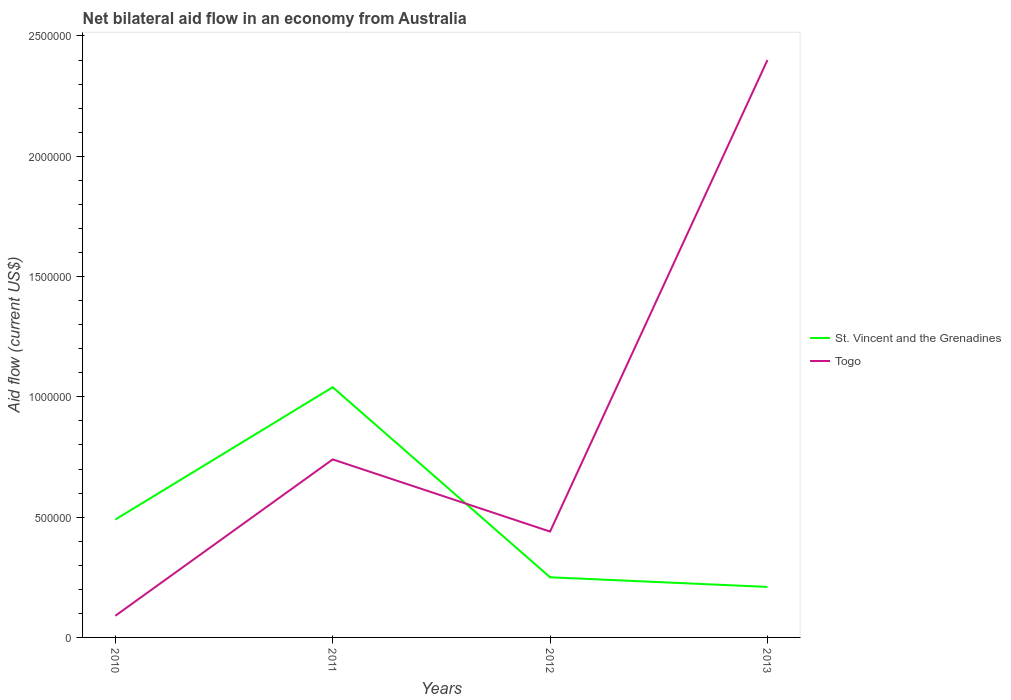Is the number of lines equal to the number of legend labels?
Provide a succinct answer. Yes. Across all years, what is the maximum net bilateral aid flow in Togo?
Give a very brief answer. 9.00e+04. In which year was the net bilateral aid flow in Togo maximum?
Offer a terse response. 2010. What is the total net bilateral aid flow in St. Vincent and the Grenadines in the graph?
Your answer should be very brief. 2.80e+05. What is the difference between the highest and the second highest net bilateral aid flow in St. Vincent and the Grenadines?
Provide a short and direct response. 8.30e+05. How many legend labels are there?
Give a very brief answer. 2. What is the title of the graph?
Your answer should be compact. Net bilateral aid flow in an economy from Australia. What is the label or title of the X-axis?
Your answer should be very brief. Years. What is the label or title of the Y-axis?
Ensure brevity in your answer.  Aid flow (current US$). What is the Aid flow (current US$) of St. Vincent and the Grenadines in 2010?
Your response must be concise. 4.90e+05. What is the Aid flow (current US$) of St. Vincent and the Grenadines in 2011?
Give a very brief answer. 1.04e+06. What is the Aid flow (current US$) in Togo in 2011?
Ensure brevity in your answer.  7.40e+05. What is the Aid flow (current US$) in St. Vincent and the Grenadines in 2012?
Provide a short and direct response. 2.50e+05. What is the Aid flow (current US$) in St. Vincent and the Grenadines in 2013?
Make the answer very short. 2.10e+05. What is the Aid flow (current US$) in Togo in 2013?
Keep it short and to the point. 2.40e+06. Across all years, what is the maximum Aid flow (current US$) in St. Vincent and the Grenadines?
Provide a succinct answer. 1.04e+06. Across all years, what is the maximum Aid flow (current US$) in Togo?
Your answer should be very brief. 2.40e+06. Across all years, what is the minimum Aid flow (current US$) of Togo?
Make the answer very short. 9.00e+04. What is the total Aid flow (current US$) of St. Vincent and the Grenadines in the graph?
Ensure brevity in your answer.  1.99e+06. What is the total Aid flow (current US$) of Togo in the graph?
Ensure brevity in your answer.  3.67e+06. What is the difference between the Aid flow (current US$) in St. Vincent and the Grenadines in 2010 and that in 2011?
Give a very brief answer. -5.50e+05. What is the difference between the Aid flow (current US$) of Togo in 2010 and that in 2011?
Offer a very short reply. -6.50e+05. What is the difference between the Aid flow (current US$) in Togo in 2010 and that in 2012?
Offer a terse response. -3.50e+05. What is the difference between the Aid flow (current US$) in St. Vincent and the Grenadines in 2010 and that in 2013?
Ensure brevity in your answer.  2.80e+05. What is the difference between the Aid flow (current US$) of Togo in 2010 and that in 2013?
Keep it short and to the point. -2.31e+06. What is the difference between the Aid flow (current US$) of St. Vincent and the Grenadines in 2011 and that in 2012?
Provide a succinct answer. 7.90e+05. What is the difference between the Aid flow (current US$) of St. Vincent and the Grenadines in 2011 and that in 2013?
Your answer should be compact. 8.30e+05. What is the difference between the Aid flow (current US$) in Togo in 2011 and that in 2013?
Your answer should be very brief. -1.66e+06. What is the difference between the Aid flow (current US$) in St. Vincent and the Grenadines in 2012 and that in 2013?
Provide a succinct answer. 4.00e+04. What is the difference between the Aid flow (current US$) in Togo in 2012 and that in 2013?
Keep it short and to the point. -1.96e+06. What is the difference between the Aid flow (current US$) of St. Vincent and the Grenadines in 2010 and the Aid flow (current US$) of Togo in 2011?
Make the answer very short. -2.50e+05. What is the difference between the Aid flow (current US$) of St. Vincent and the Grenadines in 2010 and the Aid flow (current US$) of Togo in 2013?
Offer a very short reply. -1.91e+06. What is the difference between the Aid flow (current US$) of St. Vincent and the Grenadines in 2011 and the Aid flow (current US$) of Togo in 2013?
Your answer should be compact. -1.36e+06. What is the difference between the Aid flow (current US$) in St. Vincent and the Grenadines in 2012 and the Aid flow (current US$) in Togo in 2013?
Make the answer very short. -2.15e+06. What is the average Aid flow (current US$) of St. Vincent and the Grenadines per year?
Provide a short and direct response. 4.98e+05. What is the average Aid flow (current US$) in Togo per year?
Your answer should be compact. 9.18e+05. In the year 2011, what is the difference between the Aid flow (current US$) in St. Vincent and the Grenadines and Aid flow (current US$) in Togo?
Keep it short and to the point. 3.00e+05. In the year 2013, what is the difference between the Aid flow (current US$) of St. Vincent and the Grenadines and Aid flow (current US$) of Togo?
Your answer should be compact. -2.19e+06. What is the ratio of the Aid flow (current US$) of St. Vincent and the Grenadines in 2010 to that in 2011?
Your answer should be very brief. 0.47. What is the ratio of the Aid flow (current US$) in Togo in 2010 to that in 2011?
Keep it short and to the point. 0.12. What is the ratio of the Aid flow (current US$) of St. Vincent and the Grenadines in 2010 to that in 2012?
Your answer should be compact. 1.96. What is the ratio of the Aid flow (current US$) in Togo in 2010 to that in 2012?
Offer a terse response. 0.2. What is the ratio of the Aid flow (current US$) in St. Vincent and the Grenadines in 2010 to that in 2013?
Offer a terse response. 2.33. What is the ratio of the Aid flow (current US$) of Togo in 2010 to that in 2013?
Your answer should be compact. 0.04. What is the ratio of the Aid flow (current US$) in St. Vincent and the Grenadines in 2011 to that in 2012?
Make the answer very short. 4.16. What is the ratio of the Aid flow (current US$) of Togo in 2011 to that in 2012?
Make the answer very short. 1.68. What is the ratio of the Aid flow (current US$) in St. Vincent and the Grenadines in 2011 to that in 2013?
Offer a very short reply. 4.95. What is the ratio of the Aid flow (current US$) in Togo in 2011 to that in 2013?
Ensure brevity in your answer.  0.31. What is the ratio of the Aid flow (current US$) of St. Vincent and the Grenadines in 2012 to that in 2013?
Provide a succinct answer. 1.19. What is the ratio of the Aid flow (current US$) of Togo in 2012 to that in 2013?
Your answer should be compact. 0.18. What is the difference between the highest and the second highest Aid flow (current US$) in St. Vincent and the Grenadines?
Make the answer very short. 5.50e+05. What is the difference between the highest and the second highest Aid flow (current US$) in Togo?
Ensure brevity in your answer.  1.66e+06. What is the difference between the highest and the lowest Aid flow (current US$) in St. Vincent and the Grenadines?
Ensure brevity in your answer.  8.30e+05. What is the difference between the highest and the lowest Aid flow (current US$) of Togo?
Give a very brief answer. 2.31e+06. 